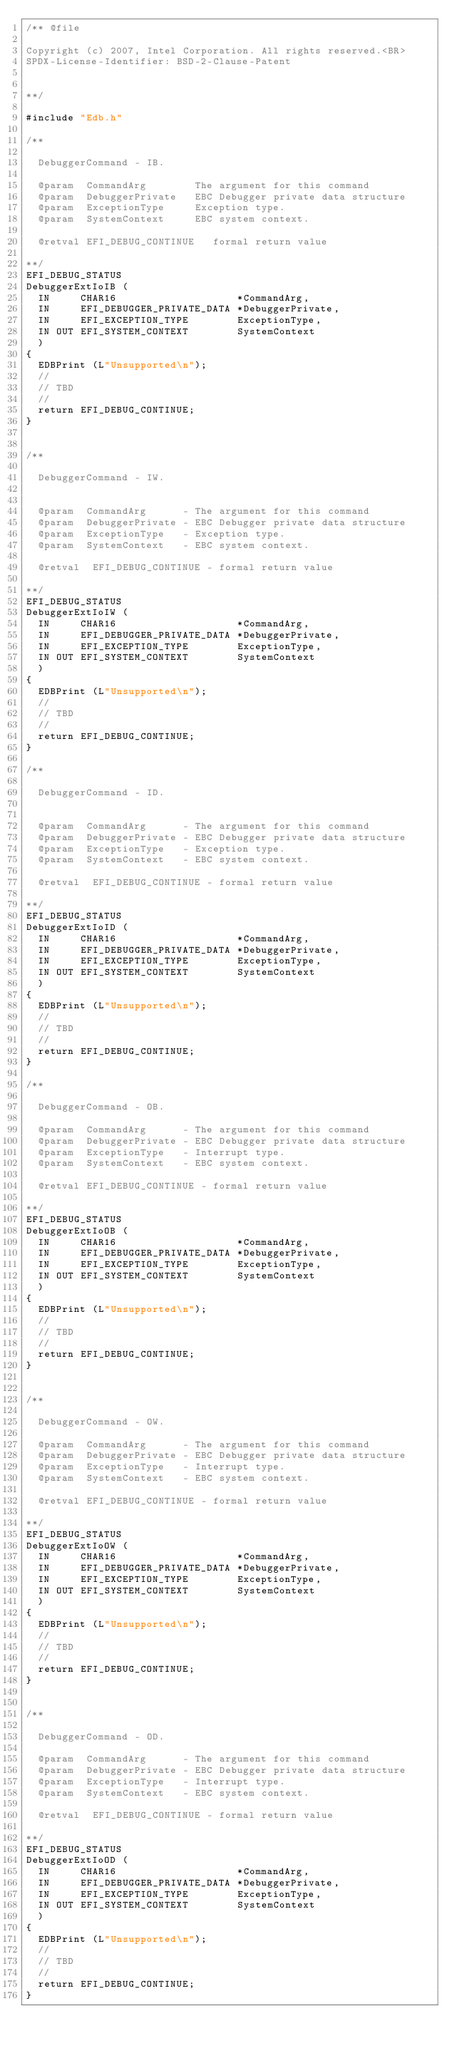<code> <loc_0><loc_0><loc_500><loc_500><_C_>/** @file

Copyright (c) 2007, Intel Corporation. All rights reserved.<BR>
SPDX-License-Identifier: BSD-2-Clause-Patent


**/

#include "Edb.h"

/**

  DebuggerCommand - IB.

  @param  CommandArg        The argument for this command
  @param  DebuggerPrivate   EBC Debugger private data structure
  @param  ExceptionType     Exception type.
  @param  SystemContext     EBC system context.

  @retval EFI_DEBUG_CONTINUE   formal return value

**/
EFI_DEBUG_STATUS
DebuggerExtIoIB (
  IN     CHAR16                    *CommandArg,
  IN     EFI_DEBUGGER_PRIVATE_DATA *DebuggerPrivate,
  IN     EFI_EXCEPTION_TYPE        ExceptionType,
  IN OUT EFI_SYSTEM_CONTEXT        SystemContext
  )
{
  EDBPrint (L"Unsupported\n");
  //
  // TBD
  //
  return EFI_DEBUG_CONTINUE;
}


/**

  DebuggerCommand - IW.


  @param  CommandArg      - The argument for this command
  @param  DebuggerPrivate - EBC Debugger private data structure
  @param  ExceptionType   - Exception type.
  @param  SystemContext   - EBC system context.

  @retval  EFI_DEBUG_CONTINUE - formal return value

**/
EFI_DEBUG_STATUS
DebuggerExtIoIW (
  IN     CHAR16                    *CommandArg,
  IN     EFI_DEBUGGER_PRIVATE_DATA *DebuggerPrivate,
  IN     EFI_EXCEPTION_TYPE        ExceptionType,
  IN OUT EFI_SYSTEM_CONTEXT        SystemContext
  )
{
  EDBPrint (L"Unsupported\n");
  //
  // TBD
  //
  return EFI_DEBUG_CONTINUE;
}

/**

  DebuggerCommand - ID.


  @param  CommandArg      - The argument for this command
  @param  DebuggerPrivate - EBC Debugger private data structure
  @param  ExceptionType   - Exception type.
  @param  SystemContext   - EBC system context.

  @retval  EFI_DEBUG_CONTINUE - formal return value

**/
EFI_DEBUG_STATUS
DebuggerExtIoID (
  IN     CHAR16                    *CommandArg,
  IN     EFI_DEBUGGER_PRIVATE_DATA *DebuggerPrivate,
  IN     EFI_EXCEPTION_TYPE        ExceptionType,
  IN OUT EFI_SYSTEM_CONTEXT        SystemContext
  )
{
  EDBPrint (L"Unsupported\n");
  //
  // TBD
  //
  return EFI_DEBUG_CONTINUE;
}

/**

  DebuggerCommand - OB.

  @param  CommandArg      - The argument for this command
  @param  DebuggerPrivate - EBC Debugger private data structure
  @param  ExceptionType   - Interrupt type.
  @param  SystemContext   - EBC system context.

  @retval EFI_DEBUG_CONTINUE - formal return value

**/
EFI_DEBUG_STATUS
DebuggerExtIoOB (
  IN     CHAR16                    *CommandArg,
  IN     EFI_DEBUGGER_PRIVATE_DATA *DebuggerPrivate,
  IN     EFI_EXCEPTION_TYPE        ExceptionType,
  IN OUT EFI_SYSTEM_CONTEXT        SystemContext
  )
{
  EDBPrint (L"Unsupported\n");
  //
  // TBD
  //
  return EFI_DEBUG_CONTINUE;
}


/**

  DebuggerCommand - OW.

  @param  CommandArg      - The argument for this command
  @param  DebuggerPrivate - EBC Debugger private data structure
  @param  ExceptionType   - Interrupt type.
  @param  SystemContext   - EBC system context.

  @retval EFI_DEBUG_CONTINUE - formal return value

**/
EFI_DEBUG_STATUS
DebuggerExtIoOW (
  IN     CHAR16                    *CommandArg,
  IN     EFI_DEBUGGER_PRIVATE_DATA *DebuggerPrivate,
  IN     EFI_EXCEPTION_TYPE        ExceptionType,
  IN OUT EFI_SYSTEM_CONTEXT        SystemContext
  )
{
  EDBPrint (L"Unsupported\n");
  //
  // TBD
  //
  return EFI_DEBUG_CONTINUE;
}


/**

  DebuggerCommand - OD.

  @param  CommandArg      - The argument for this command
  @param  DebuggerPrivate - EBC Debugger private data structure
  @param  ExceptionType   - Interrupt type.
  @param  SystemContext   - EBC system context.

  @retval  EFI_DEBUG_CONTINUE - formal return value

**/
EFI_DEBUG_STATUS
DebuggerExtIoOD (
  IN     CHAR16                    *CommandArg,
  IN     EFI_DEBUGGER_PRIVATE_DATA *DebuggerPrivate,
  IN     EFI_EXCEPTION_TYPE        ExceptionType,
  IN OUT EFI_SYSTEM_CONTEXT        SystemContext
  )
{
  EDBPrint (L"Unsupported\n");
  //
  // TBD
  //
  return EFI_DEBUG_CONTINUE;
}
</code> 